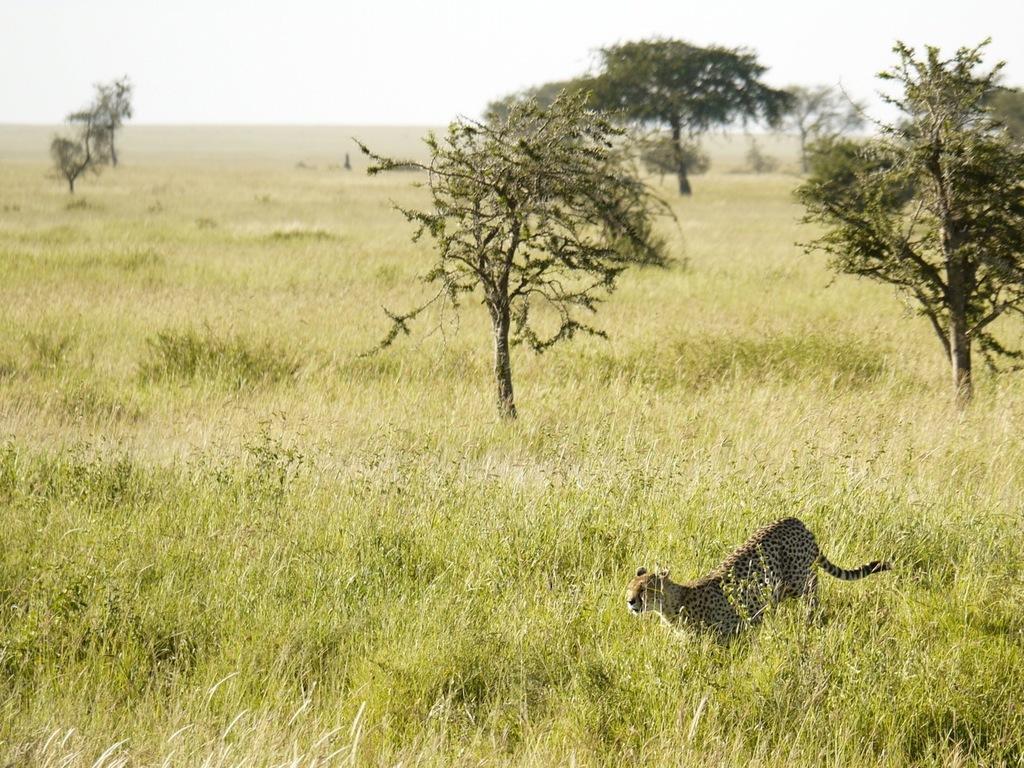Describe this image in one or two sentences. This is an outside view. Here I can see the grass and some trees. On the right side, I can see a cheetah is running towards the left side. At the top I can see the sky. 